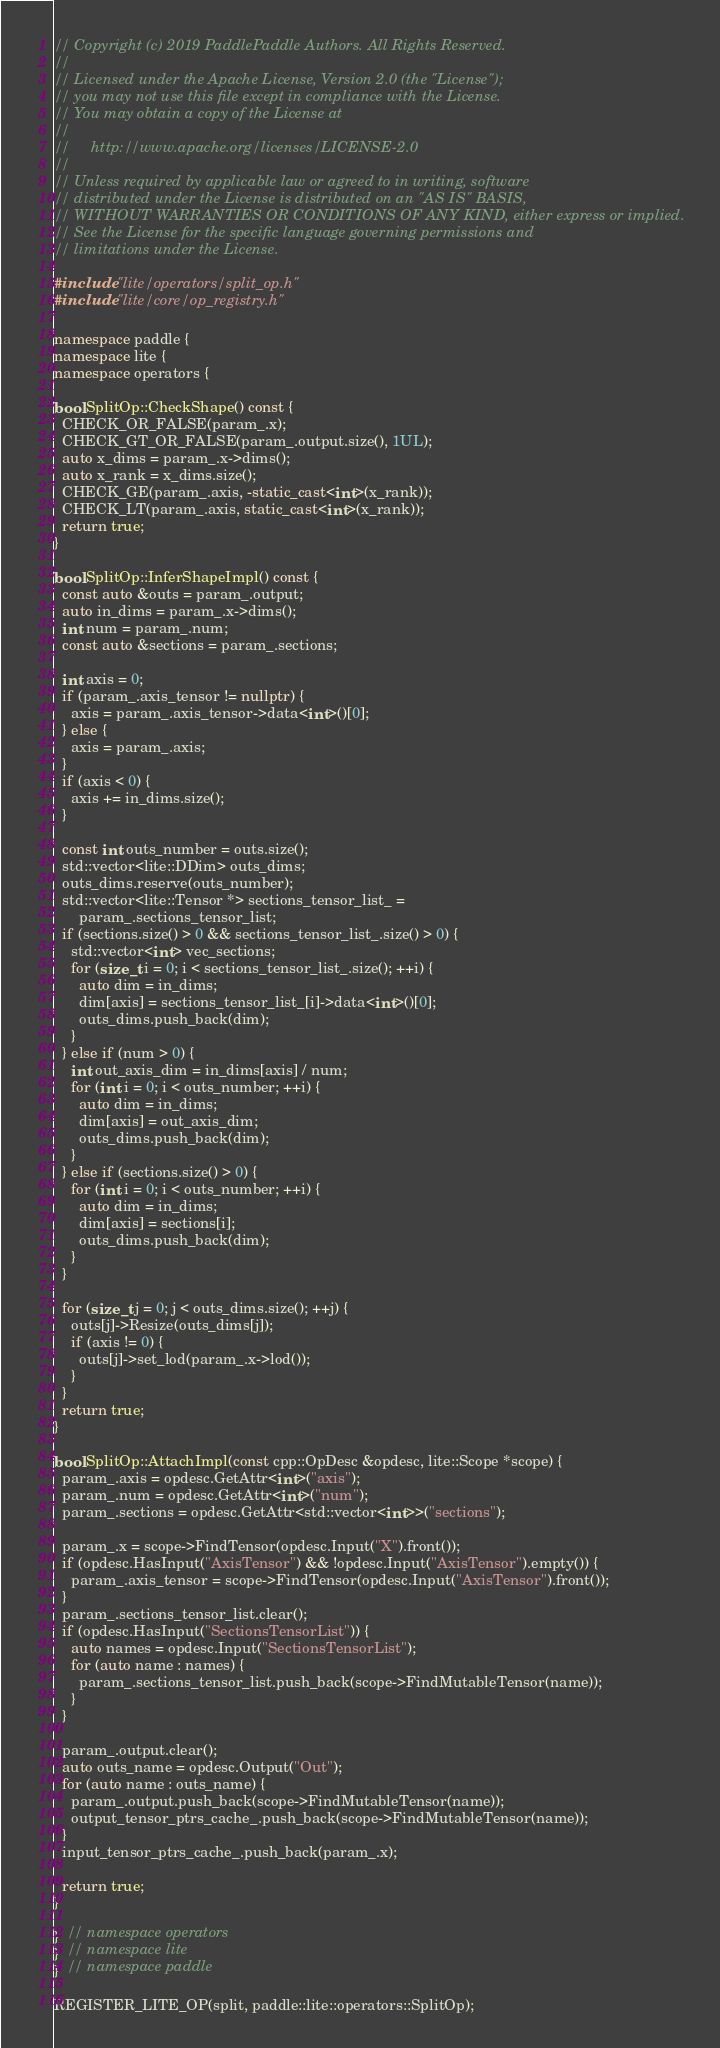Convert code to text. <code><loc_0><loc_0><loc_500><loc_500><_C++_>// Copyright (c) 2019 PaddlePaddle Authors. All Rights Reserved.
//
// Licensed under the Apache License, Version 2.0 (the "License");
// you may not use this file except in compliance with the License.
// You may obtain a copy of the License at
//
//     http://www.apache.org/licenses/LICENSE-2.0
//
// Unless required by applicable law or agreed to in writing, software
// distributed under the License is distributed on an "AS IS" BASIS,
// WITHOUT WARRANTIES OR CONDITIONS OF ANY KIND, either express or implied.
// See the License for the specific language governing permissions and
// limitations under the License.

#include "lite/operators/split_op.h"
#include "lite/core/op_registry.h"

namespace paddle {
namespace lite {
namespace operators {

bool SplitOp::CheckShape() const {
  CHECK_OR_FALSE(param_.x);
  CHECK_GT_OR_FALSE(param_.output.size(), 1UL);
  auto x_dims = param_.x->dims();
  auto x_rank = x_dims.size();
  CHECK_GE(param_.axis, -static_cast<int>(x_rank));
  CHECK_LT(param_.axis, static_cast<int>(x_rank));
  return true;
}

bool SplitOp::InferShapeImpl() const {
  const auto &outs = param_.output;
  auto in_dims = param_.x->dims();
  int num = param_.num;
  const auto &sections = param_.sections;

  int axis = 0;
  if (param_.axis_tensor != nullptr) {
    axis = param_.axis_tensor->data<int>()[0];
  } else {
    axis = param_.axis;
  }
  if (axis < 0) {
    axis += in_dims.size();
  }

  const int outs_number = outs.size();
  std::vector<lite::DDim> outs_dims;
  outs_dims.reserve(outs_number);
  std::vector<lite::Tensor *> sections_tensor_list_ =
      param_.sections_tensor_list;
  if (sections.size() > 0 && sections_tensor_list_.size() > 0) {
    std::vector<int> vec_sections;
    for (size_t i = 0; i < sections_tensor_list_.size(); ++i) {
      auto dim = in_dims;
      dim[axis] = sections_tensor_list_[i]->data<int>()[0];
      outs_dims.push_back(dim);
    }
  } else if (num > 0) {
    int out_axis_dim = in_dims[axis] / num;
    for (int i = 0; i < outs_number; ++i) {
      auto dim = in_dims;
      dim[axis] = out_axis_dim;
      outs_dims.push_back(dim);
    }
  } else if (sections.size() > 0) {
    for (int i = 0; i < outs_number; ++i) {
      auto dim = in_dims;
      dim[axis] = sections[i];
      outs_dims.push_back(dim);
    }
  }

  for (size_t j = 0; j < outs_dims.size(); ++j) {
    outs[j]->Resize(outs_dims[j]);
    if (axis != 0) {
      outs[j]->set_lod(param_.x->lod());
    }
  }
  return true;
}

bool SplitOp::AttachImpl(const cpp::OpDesc &opdesc, lite::Scope *scope) {
  param_.axis = opdesc.GetAttr<int>("axis");
  param_.num = opdesc.GetAttr<int>("num");
  param_.sections = opdesc.GetAttr<std::vector<int>>("sections");

  param_.x = scope->FindTensor(opdesc.Input("X").front());
  if (opdesc.HasInput("AxisTensor") && !opdesc.Input("AxisTensor").empty()) {
    param_.axis_tensor = scope->FindTensor(opdesc.Input("AxisTensor").front());
  }
  param_.sections_tensor_list.clear();
  if (opdesc.HasInput("SectionsTensorList")) {
    auto names = opdesc.Input("SectionsTensorList");
    for (auto name : names) {
      param_.sections_tensor_list.push_back(scope->FindMutableTensor(name));
    }
  }

  param_.output.clear();
  auto outs_name = opdesc.Output("Out");
  for (auto name : outs_name) {
    param_.output.push_back(scope->FindMutableTensor(name));
    output_tensor_ptrs_cache_.push_back(scope->FindMutableTensor(name));
  }
  input_tensor_ptrs_cache_.push_back(param_.x);

  return true;
}

}  // namespace operators
}  // namespace lite
}  // namespace paddle

REGISTER_LITE_OP(split, paddle::lite::operators::SplitOp);
</code> 